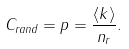<formula> <loc_0><loc_0><loc_500><loc_500>C _ { r a n d } = p = \frac { \langle k \rangle } { n _ { r } } .</formula> 